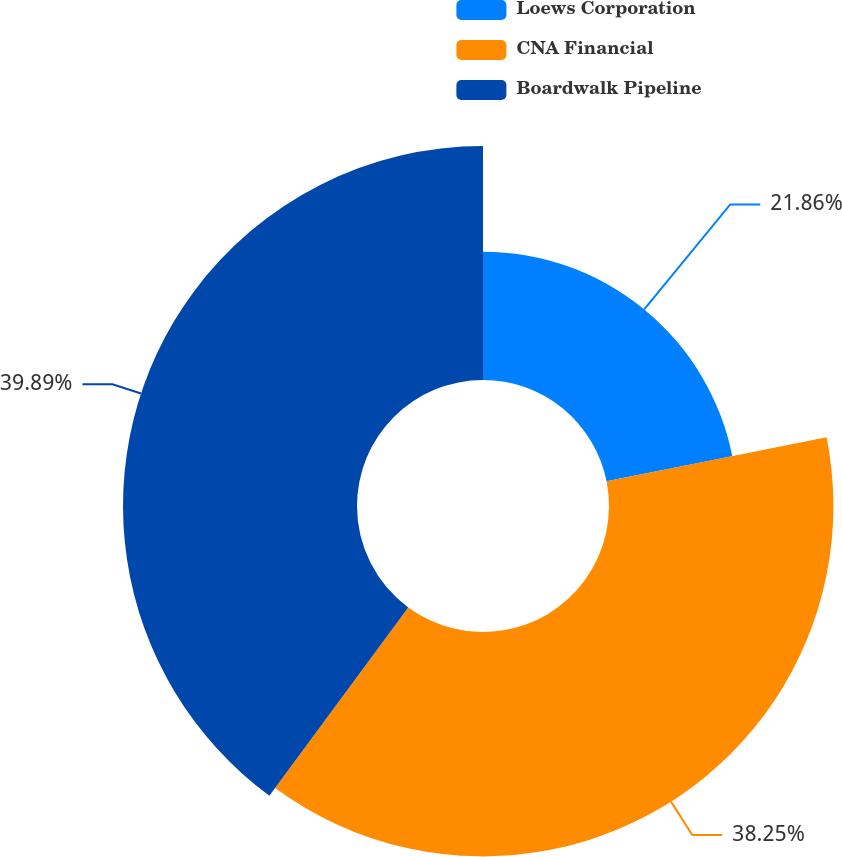<chart> <loc_0><loc_0><loc_500><loc_500><pie_chart><fcel>Loews Corporation<fcel>CNA Financial<fcel>Boardwalk Pipeline<nl><fcel>21.86%<fcel>38.25%<fcel>39.89%<nl></chart> 